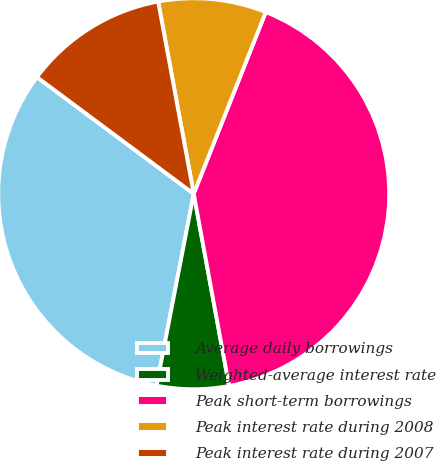<chart> <loc_0><loc_0><loc_500><loc_500><pie_chart><fcel>Average daily borrowings<fcel>Weighted-average interest rate<fcel>Peak short-term borrowings<fcel>Peak interest rate during 2008<fcel>Peak interest rate during 2007<nl><fcel>32.14%<fcel>5.94%<fcel>41.1%<fcel>8.92%<fcel>11.91%<nl></chart> 